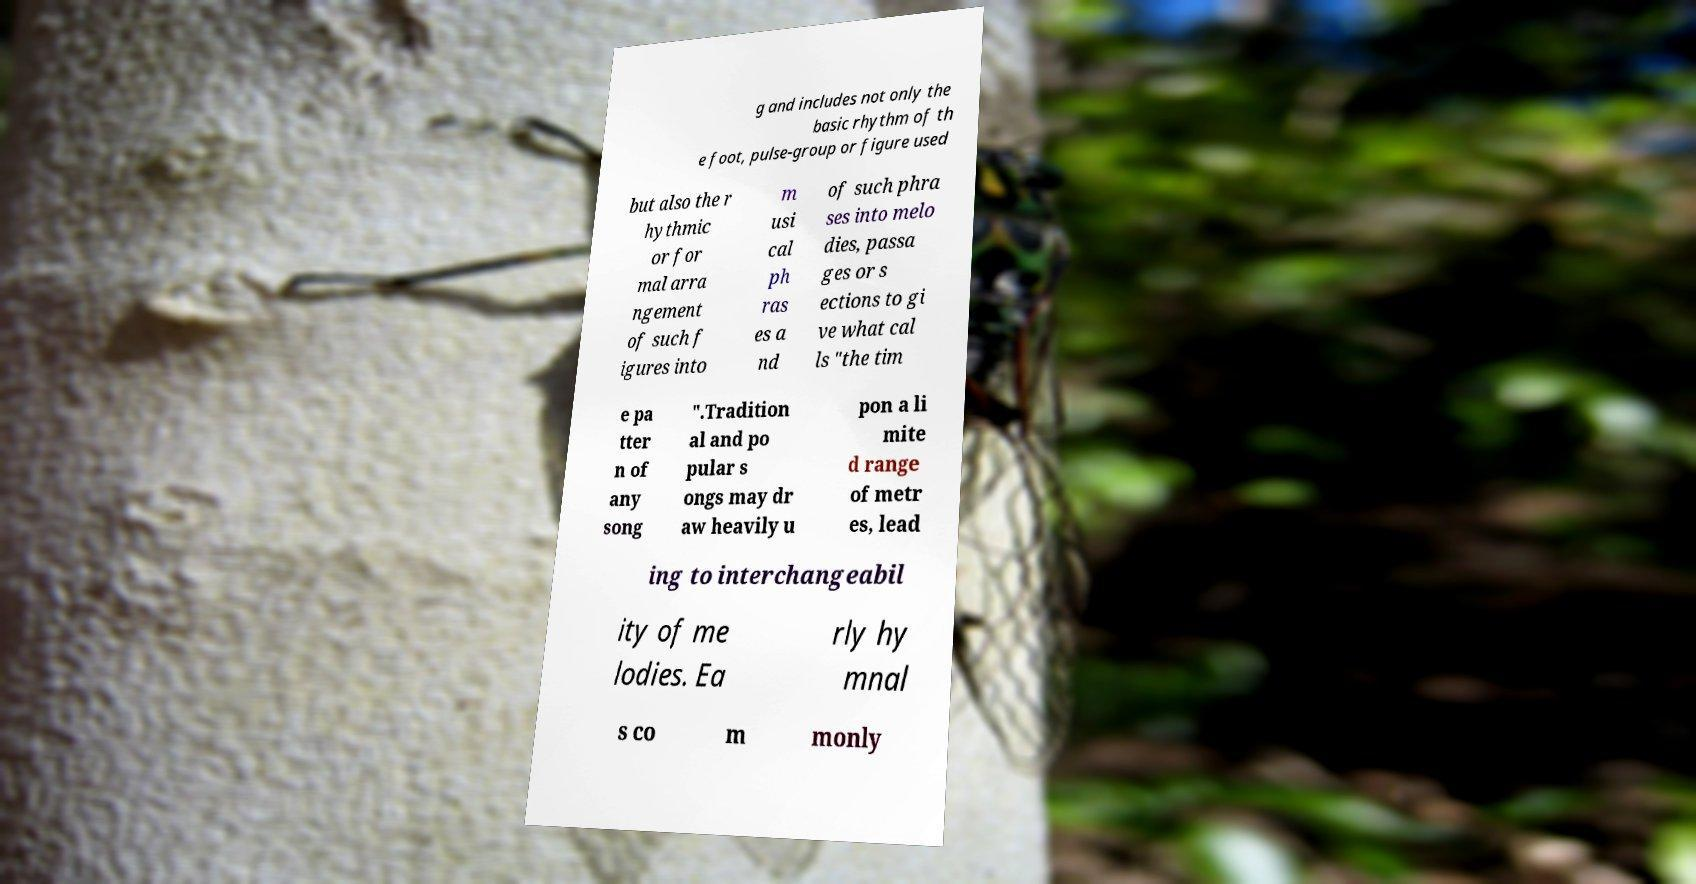Could you extract and type out the text from this image? g and includes not only the basic rhythm of th e foot, pulse-group or figure used but also the r hythmic or for mal arra ngement of such f igures into m usi cal ph ras es a nd of such phra ses into melo dies, passa ges or s ections to gi ve what cal ls "the tim e pa tter n of any song ".Tradition al and po pular s ongs may dr aw heavily u pon a li mite d range of metr es, lead ing to interchangeabil ity of me lodies. Ea rly hy mnal s co m monly 